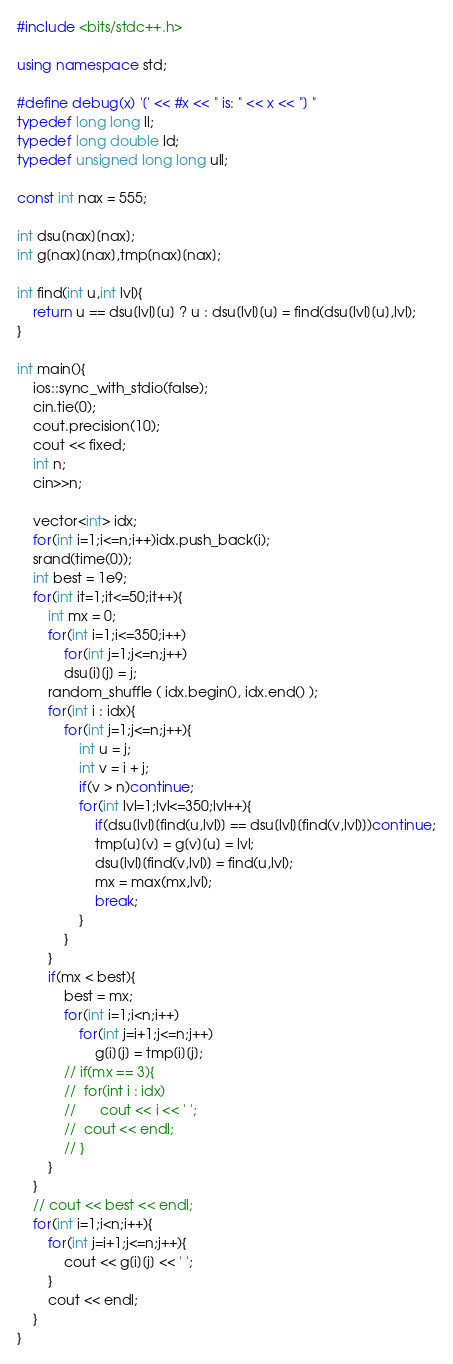Convert code to text. <code><loc_0><loc_0><loc_500><loc_500><_C++_>#include <bits/stdc++.h>

using namespace std;

#define debug(x) '[' << #x << " is: " << x << "] "
typedef long long ll;
typedef long double ld;
typedef unsigned long long ull;

const int nax = 555;

int dsu[nax][nax];
int g[nax][nax],tmp[nax][nax];

int find(int u,int lvl){
	return u == dsu[lvl][u] ? u : dsu[lvl][u] = find(dsu[lvl][u],lvl);
}

int main(){
	ios::sync_with_stdio(false);
	cin.tie(0);
	cout.precision(10);
	cout << fixed;
	int n;
	cin>>n;

	vector<int> idx;
	for(int i=1;i<=n;i++)idx.push_back(i);
	srand(time(0));
	int best = 1e9;
	for(int it=1;it<=50;it++){
		int mx = 0;
		for(int i=1;i<=350;i++)
			for(int j=1;j<=n;j++)
			dsu[i][j] = j;
		random_shuffle ( idx.begin(), idx.end() );
		for(int i : idx){
			for(int j=1;j<=n;j++){
				int u = j;
				int v = i + j;
				if(v > n)continue;
				for(int lvl=1;lvl<=350;lvl++){
					if(dsu[lvl][find(u,lvl)] == dsu[lvl][find(v,lvl)])continue;
					tmp[u][v] = g[v][u] = lvl;
					dsu[lvl][find(v,lvl)] = find(u,lvl);
					mx = max(mx,lvl);
					break;
				}
			}
		}
		if(mx < best){
			best = mx;
			for(int i=1;i<n;i++)
				for(int j=i+1;j<=n;j++)
					g[i][j] = tmp[i][j];
			// if(mx == 3){
			// 	for(int i : idx)
			// 		cout << i << ' ';
			// 	cout << endl;
			// }
		}
	}
	// cout << best << endl;
	for(int i=1;i<n;i++){
		for(int j=i+1;j<=n;j++){
			cout << g[i][j] << ' ';
		}
		cout << endl;
	}
}</code> 